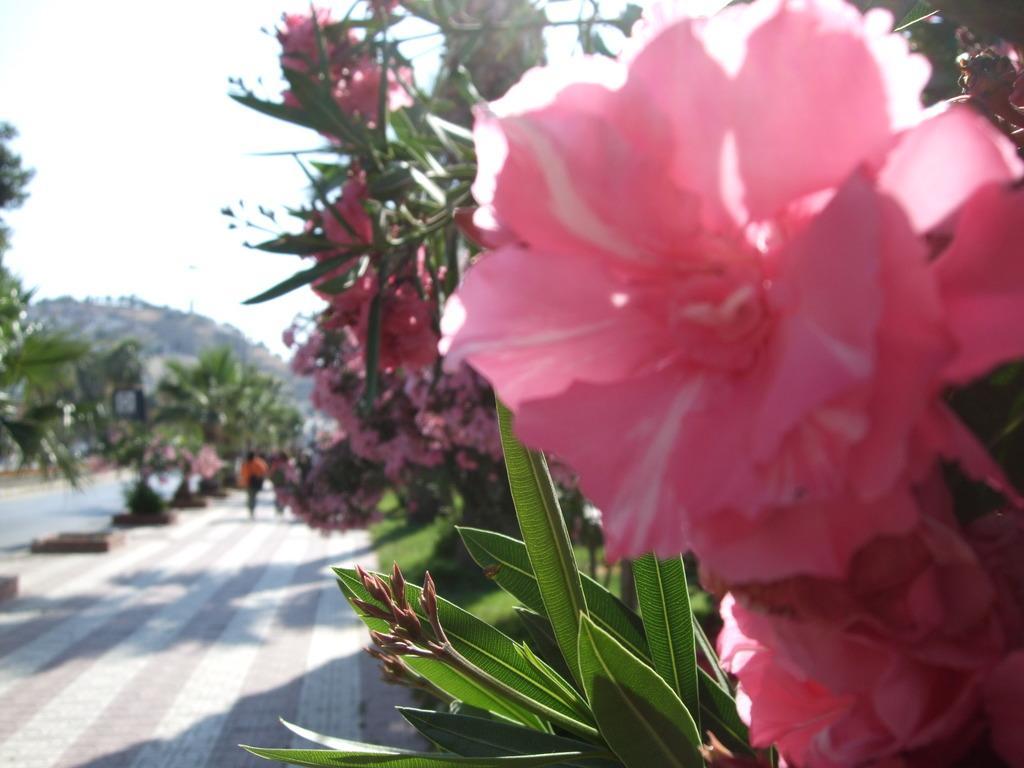How would you summarize this image in a sentence or two? In this picture we can see there are plants with flowers, buds and leaves. On the left side of the flowers, there are people on the walkway. In front of the people there are trees, a hill and the sky. 